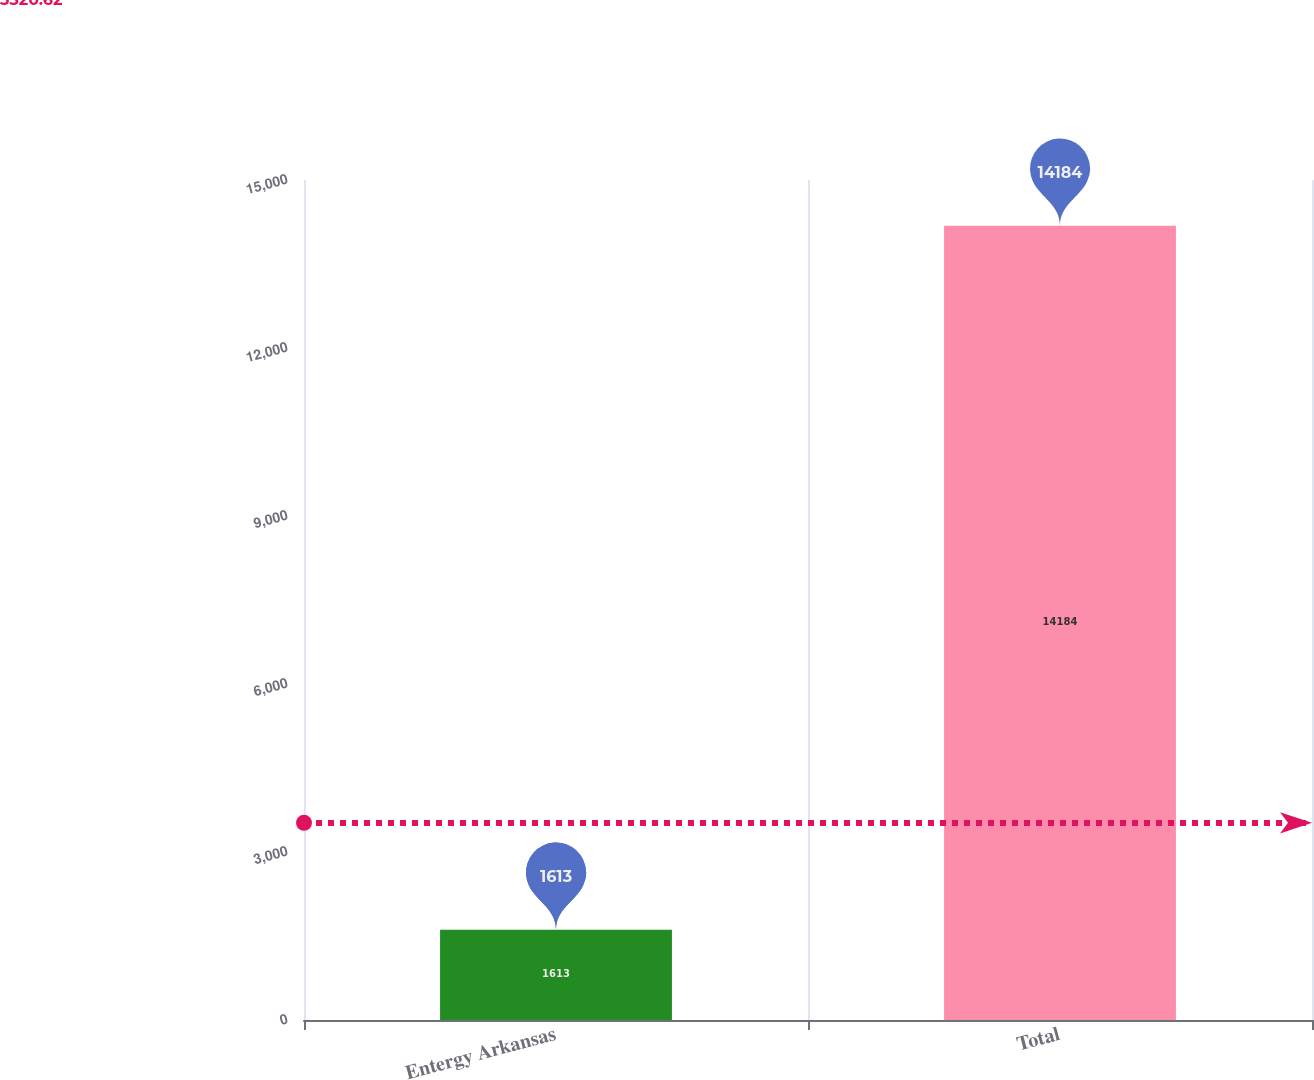Convert chart. <chart><loc_0><loc_0><loc_500><loc_500><bar_chart><fcel>Entergy Arkansas<fcel>Total<nl><fcel>1613<fcel>14184<nl></chart> 